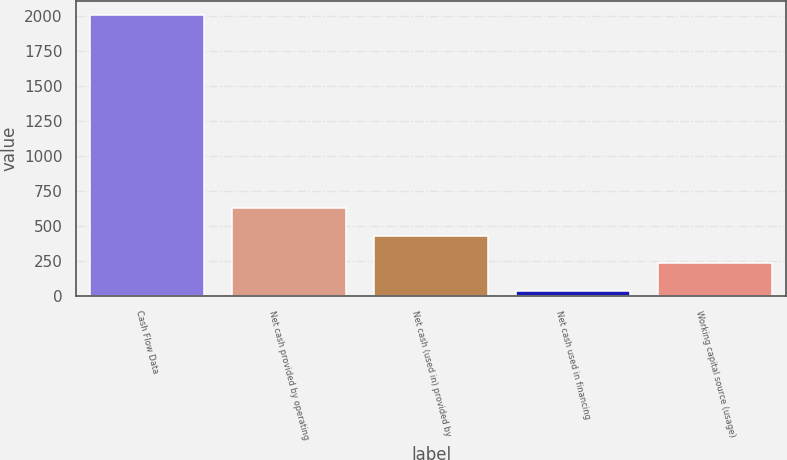Convert chart to OTSL. <chart><loc_0><loc_0><loc_500><loc_500><bar_chart><fcel>Cash Flow Data<fcel>Net cash provided by operating<fcel>Net cash (used in) provided by<fcel>Net cash used in financing<fcel>Working capital source (usage)<nl><fcel>2007<fcel>628.21<fcel>431.24<fcel>37.3<fcel>234.27<nl></chart> 